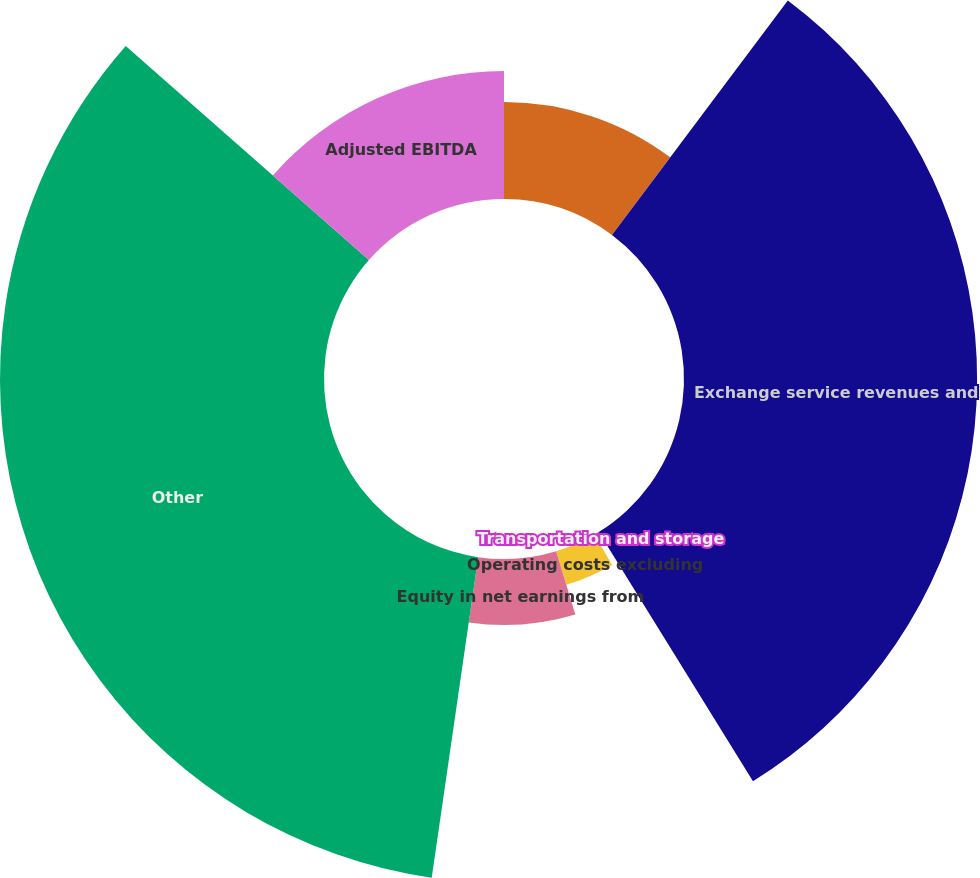<chart> <loc_0><loc_0><loc_500><loc_500><pie_chart><fcel>NGL and condensate sales<fcel>Exchange service revenues and<fcel>Transportation and storage<fcel>Operating costs excluding<fcel>Equity in net earnings from<fcel>Other<fcel>Adjusted EBITDA<nl><fcel>10.24%<fcel>30.94%<fcel>0.44%<fcel>3.7%<fcel>6.97%<fcel>34.2%<fcel>13.51%<nl></chart> 